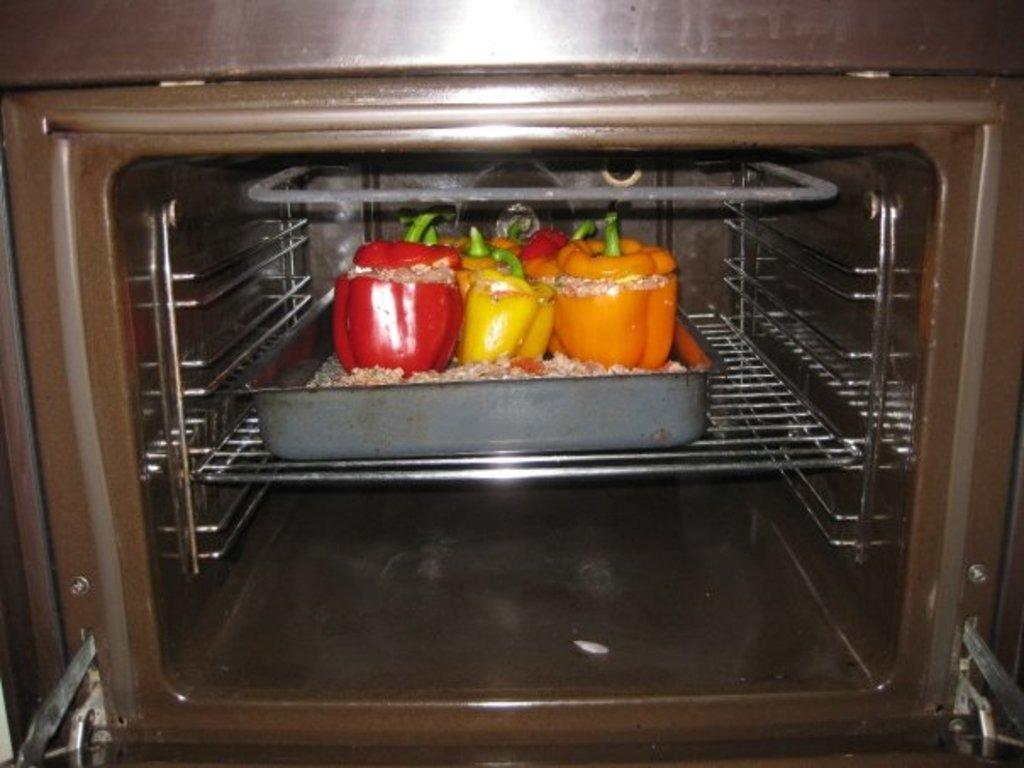What type of food items are present in the image? There are many capsicums in the image. How are the capsicums arranged or placed in the image? The capsicums are kept on a tray. Where is the tray with capsicums located? The tray is inside an oven. What type of card can be seen being charged in the image? There is no card present in the image, and therefore no charging activity can be observed. 